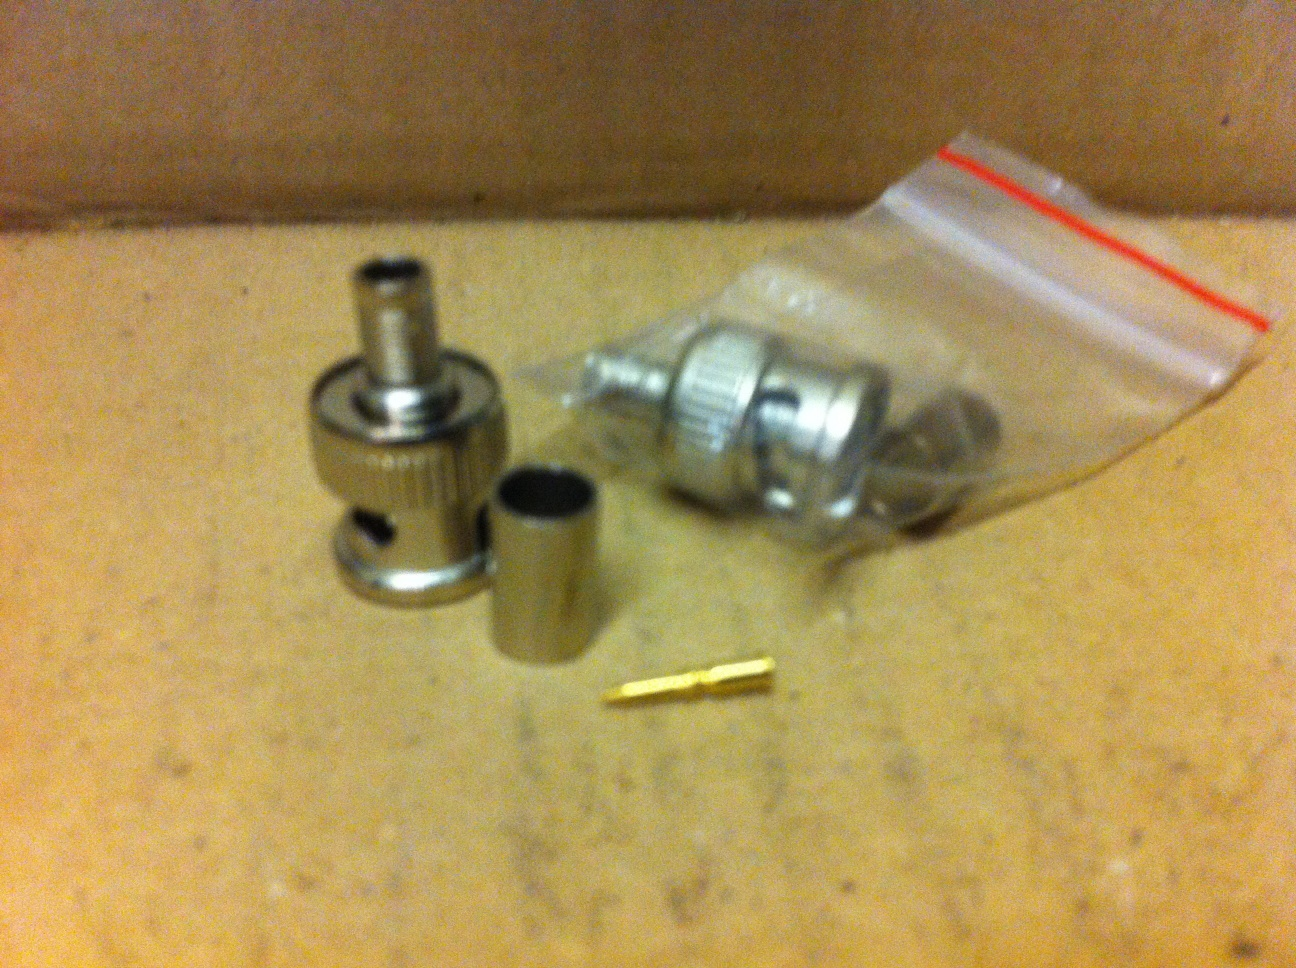Can you identify all the components in this image? Certainly! The image appears to show several components typically found in a coaxial cable connector assembly. There is a coaxial connector housing, a barrel or sleeve (typically used to crimp the connector onto the cable), a small brass pin (which is likely a conductor pin), and possibly a ferrule or other small parts to complete the assembly. 